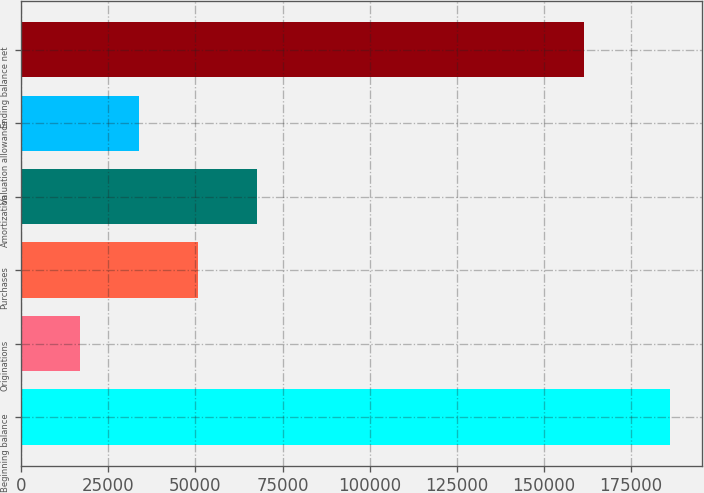Convert chart. <chart><loc_0><loc_0><loc_500><loc_500><bar_chart><fcel>Beginning balance<fcel>Originations<fcel>Purchases<fcel>Amortization<fcel>Valuation allowance<fcel>Ending balance net<nl><fcel>186225<fcel>16928<fcel>50787.4<fcel>67717.1<fcel>33857.7<fcel>161433<nl></chart> 